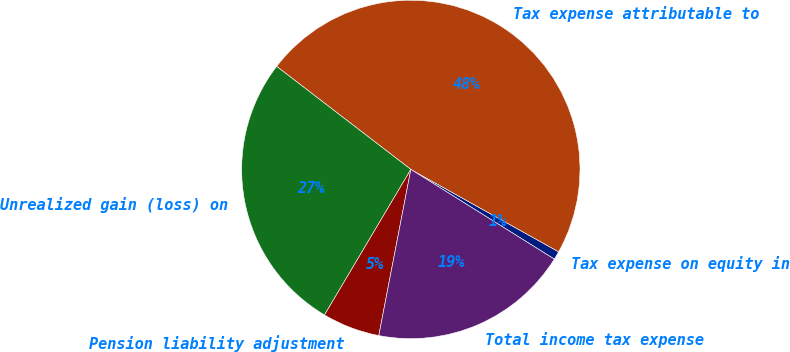Convert chart to OTSL. <chart><loc_0><loc_0><loc_500><loc_500><pie_chart><fcel>Tax expense on equity in<fcel>Tax expense attributable to<fcel>Unrealized gain (loss) on<fcel>Pension liability adjustment<fcel>Total income tax expense<nl><fcel>0.8%<fcel>47.67%<fcel>26.9%<fcel>5.49%<fcel>19.14%<nl></chart> 